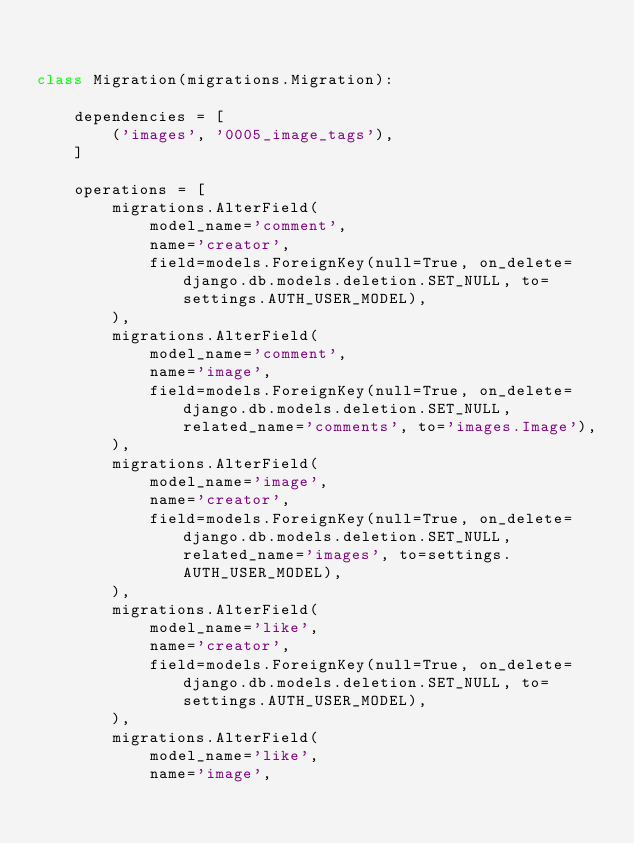<code> <loc_0><loc_0><loc_500><loc_500><_Python_>

class Migration(migrations.Migration):

    dependencies = [
        ('images', '0005_image_tags'),
    ]

    operations = [
        migrations.AlterField(
            model_name='comment',
            name='creator',
            field=models.ForeignKey(null=True, on_delete=django.db.models.deletion.SET_NULL, to=settings.AUTH_USER_MODEL),
        ),
        migrations.AlterField(
            model_name='comment',
            name='image',
            field=models.ForeignKey(null=True, on_delete=django.db.models.deletion.SET_NULL, related_name='comments', to='images.Image'),
        ),
        migrations.AlterField(
            model_name='image',
            name='creator',
            field=models.ForeignKey(null=True, on_delete=django.db.models.deletion.SET_NULL, related_name='images', to=settings.AUTH_USER_MODEL),
        ),
        migrations.AlterField(
            model_name='like',
            name='creator',
            field=models.ForeignKey(null=True, on_delete=django.db.models.deletion.SET_NULL, to=settings.AUTH_USER_MODEL),
        ),
        migrations.AlterField(
            model_name='like',
            name='image',</code> 